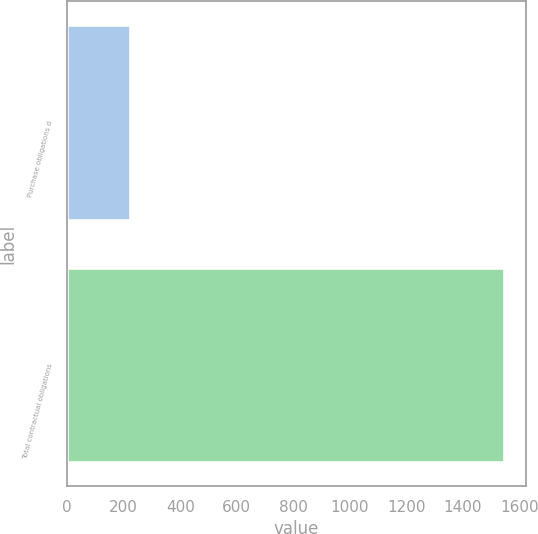<chart> <loc_0><loc_0><loc_500><loc_500><bar_chart><fcel>Purchase obligations d<fcel>Total contractual obligations<nl><fcel>221<fcel>1545<nl></chart> 